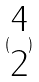<formula> <loc_0><loc_0><loc_500><loc_500>( \begin{matrix} 4 \\ 2 \end{matrix} )</formula> 